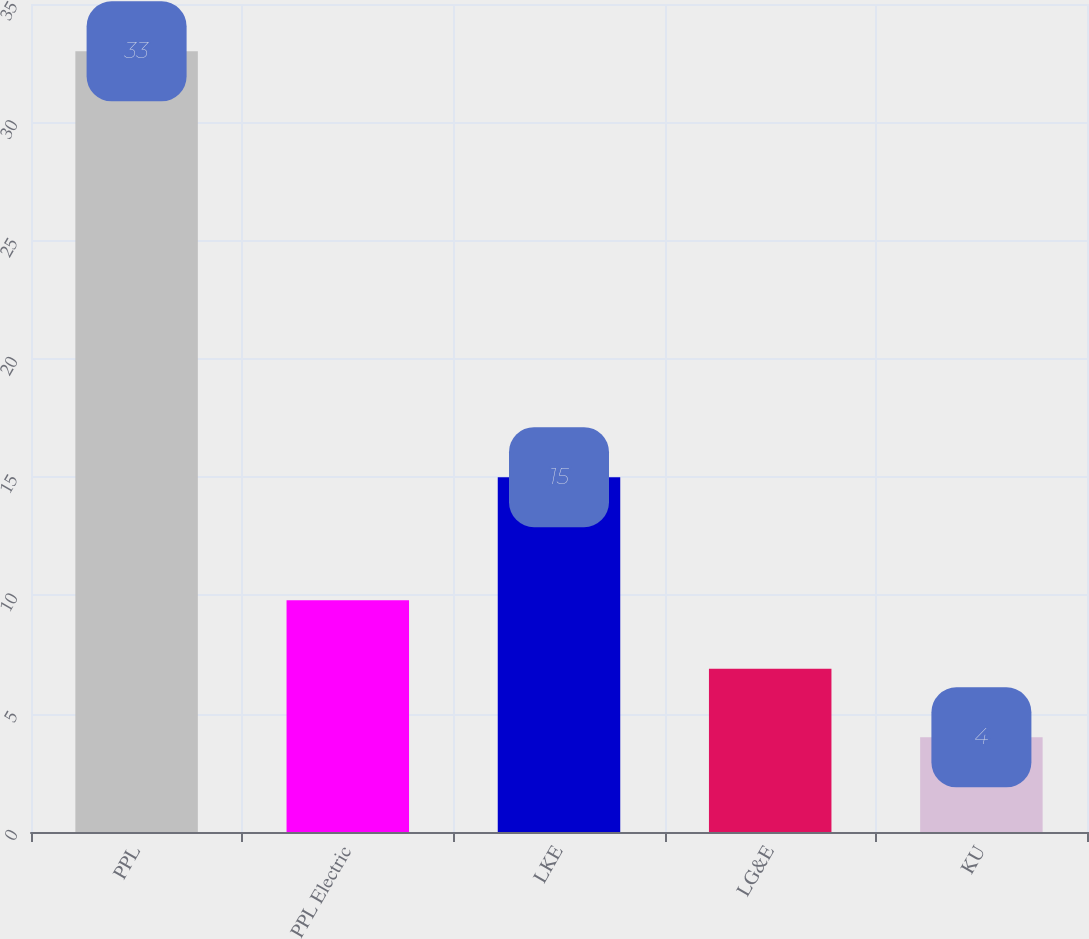<chart> <loc_0><loc_0><loc_500><loc_500><bar_chart><fcel>PPL<fcel>PPL Electric<fcel>LKE<fcel>LG&E<fcel>KU<nl><fcel>33<fcel>9.8<fcel>15<fcel>6.9<fcel>4<nl></chart> 